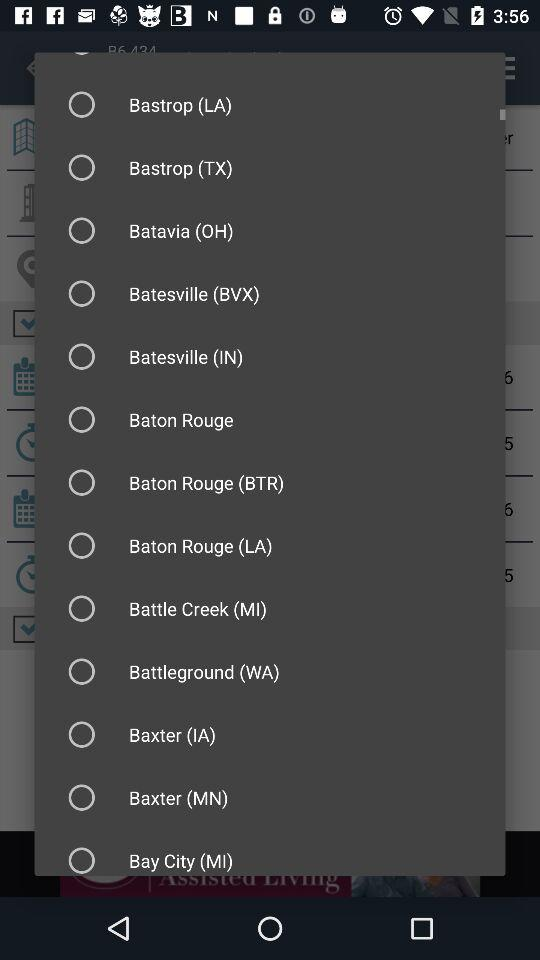What is the number of flights? The number of flights is zero. 